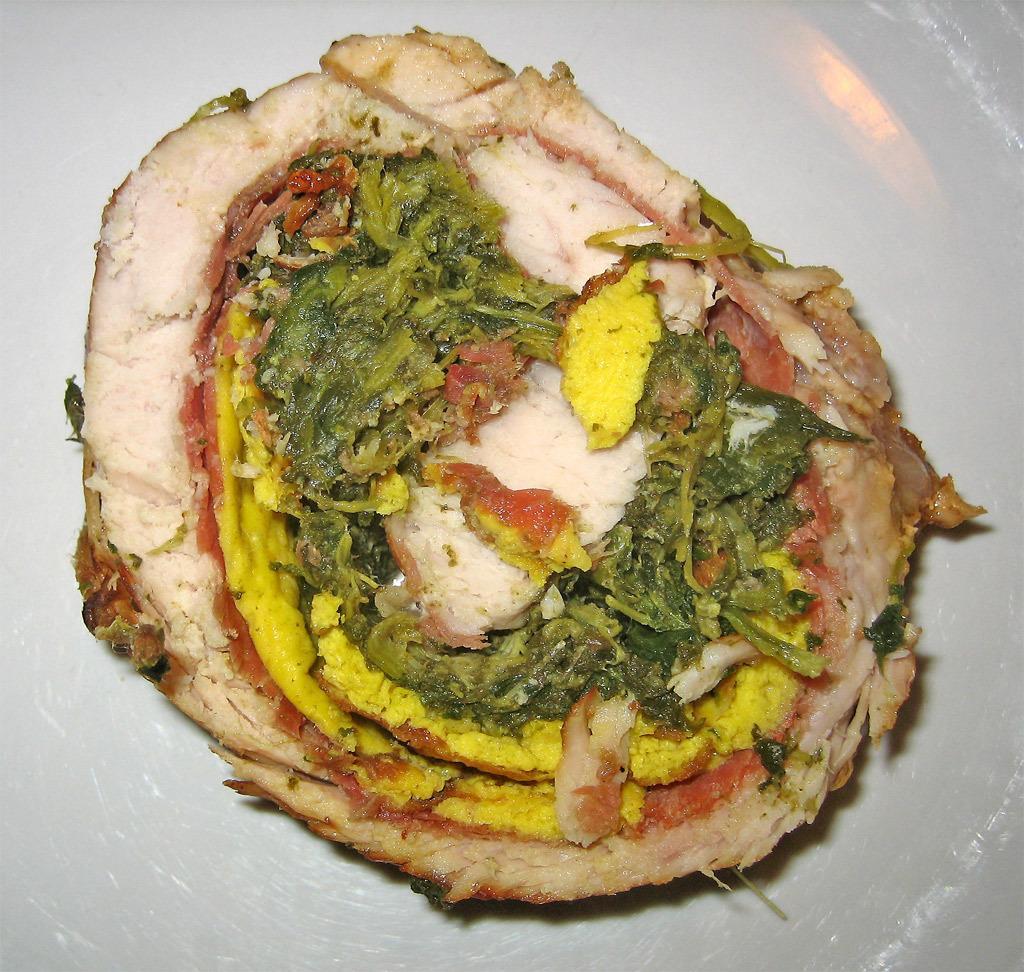Please provide a concise description of this image. In this picture, we see an edible. In the background, it is white in color. It might be a plate or a tray. 